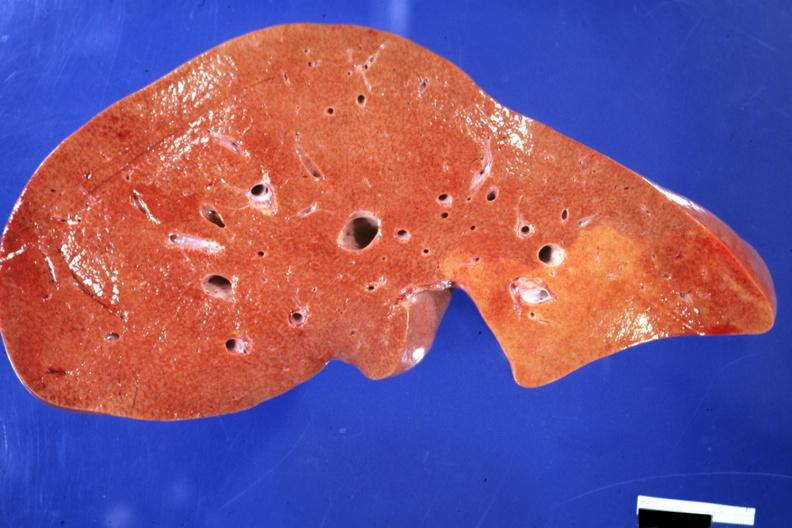what does this image show?
Answer the question using a single word or phrase. Frontal section typical enlarged fatty liver with focal nutmeg areas 